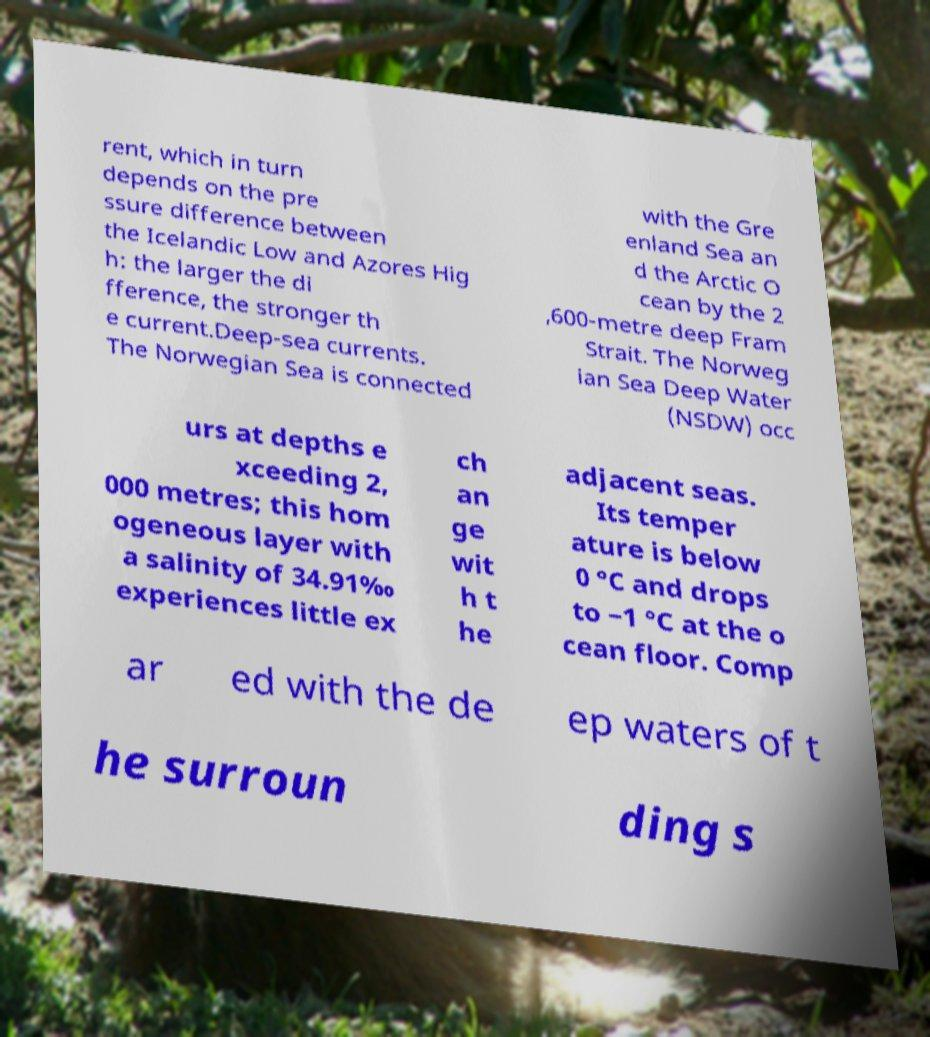Could you assist in decoding the text presented in this image and type it out clearly? rent, which in turn depends on the pre ssure difference between the Icelandic Low and Azores Hig h: the larger the di fference, the stronger th e current.Deep-sea currents. The Norwegian Sea is connected with the Gre enland Sea an d the Arctic O cean by the 2 ,600-metre deep Fram Strait. The Norweg ian Sea Deep Water (NSDW) occ urs at depths e xceeding 2, 000 metres; this hom ogeneous layer with a salinity of 34.91‰ experiences little ex ch an ge wit h t he adjacent seas. Its temper ature is below 0 °C and drops to −1 °C at the o cean floor. Comp ar ed with the de ep waters of t he surroun ding s 